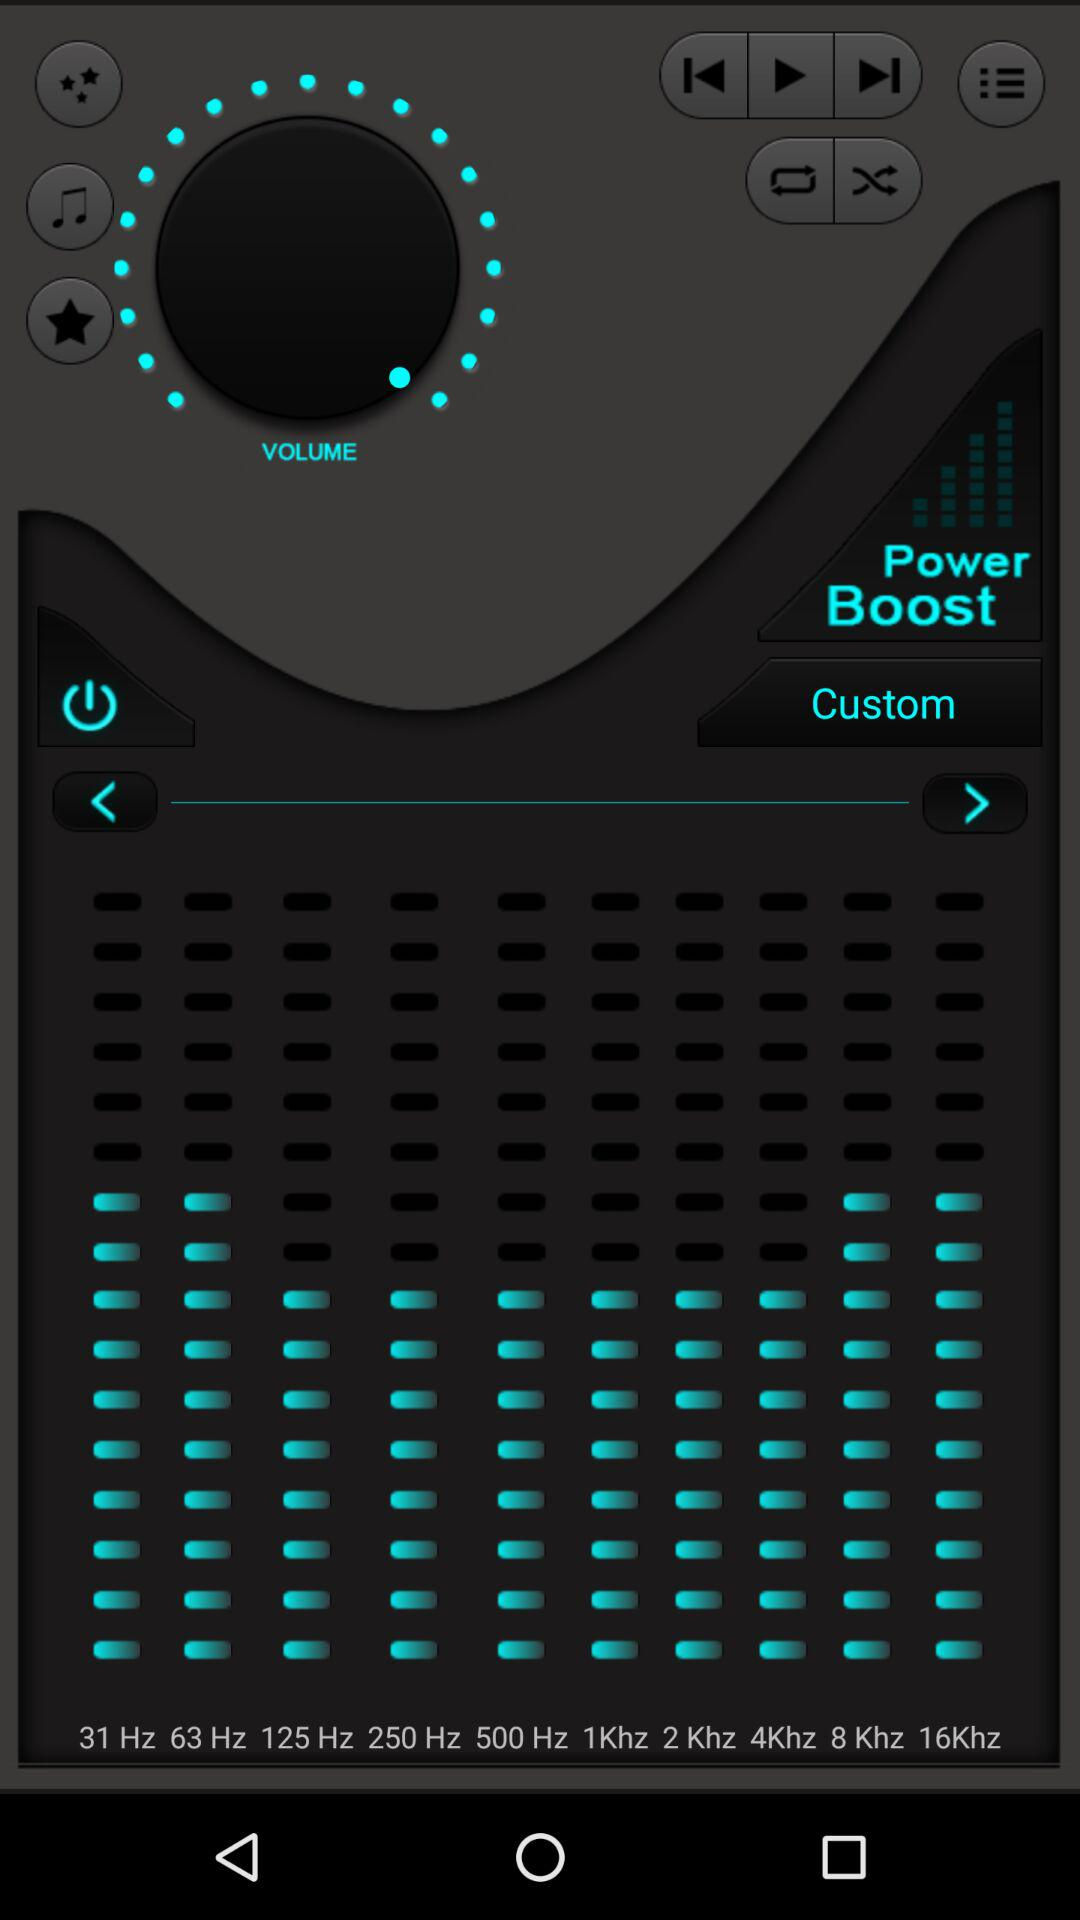How many hz are there between 1Khz and 8Khz?
Answer the question using a single word or phrase. 7 